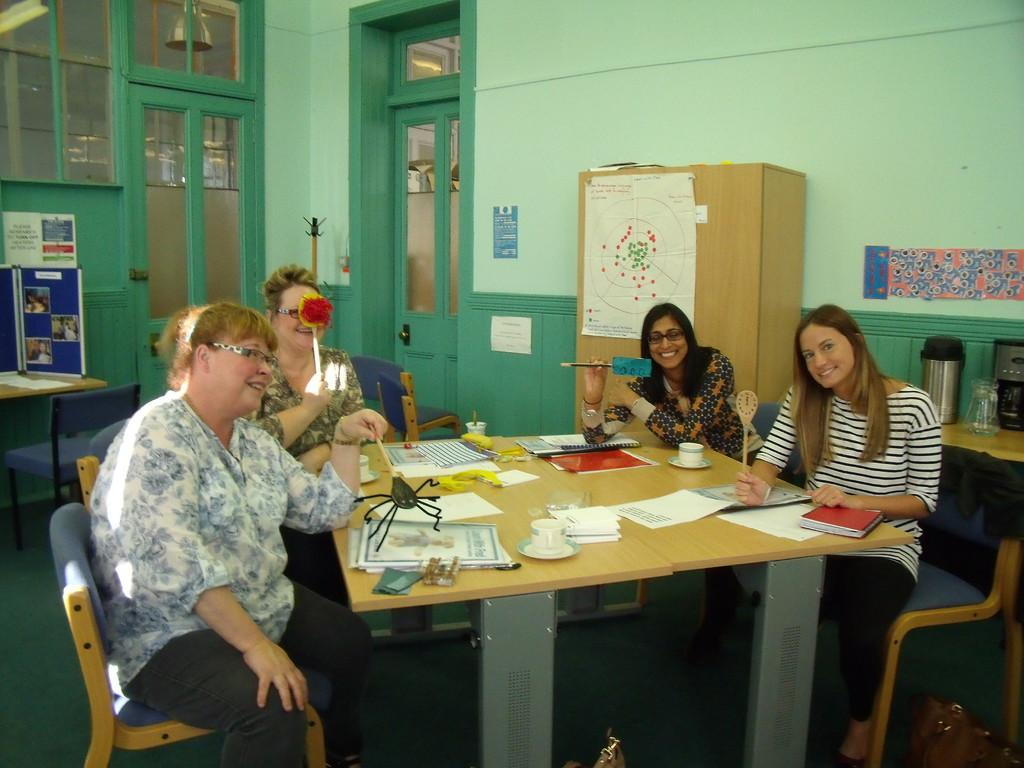What is one of the main structures visible in the image? There is a door in the image. What is another feature of the room in the image? There is a wall in the image. What are the people in the image doing? The people are sitting on chairs in the image. What is on the table in the image? There is a cup, a saucer, books, and papers on the table in the image. What type of flowers can be seen growing out of the cup in the image? There are no flowers present in the image, and the cup is not depicted as a flower pot. 